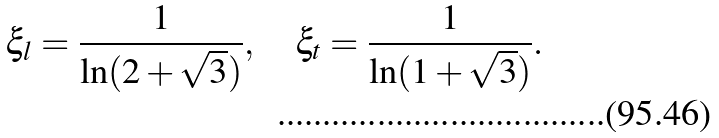Convert formula to latex. <formula><loc_0><loc_0><loc_500><loc_500>\xi _ { l } = \frac { 1 } { \ln ( 2 + \sqrt { 3 } ) } , \quad \xi _ { t } = \frac { 1 } { \ln ( 1 + \sqrt { 3 } ) } .</formula> 